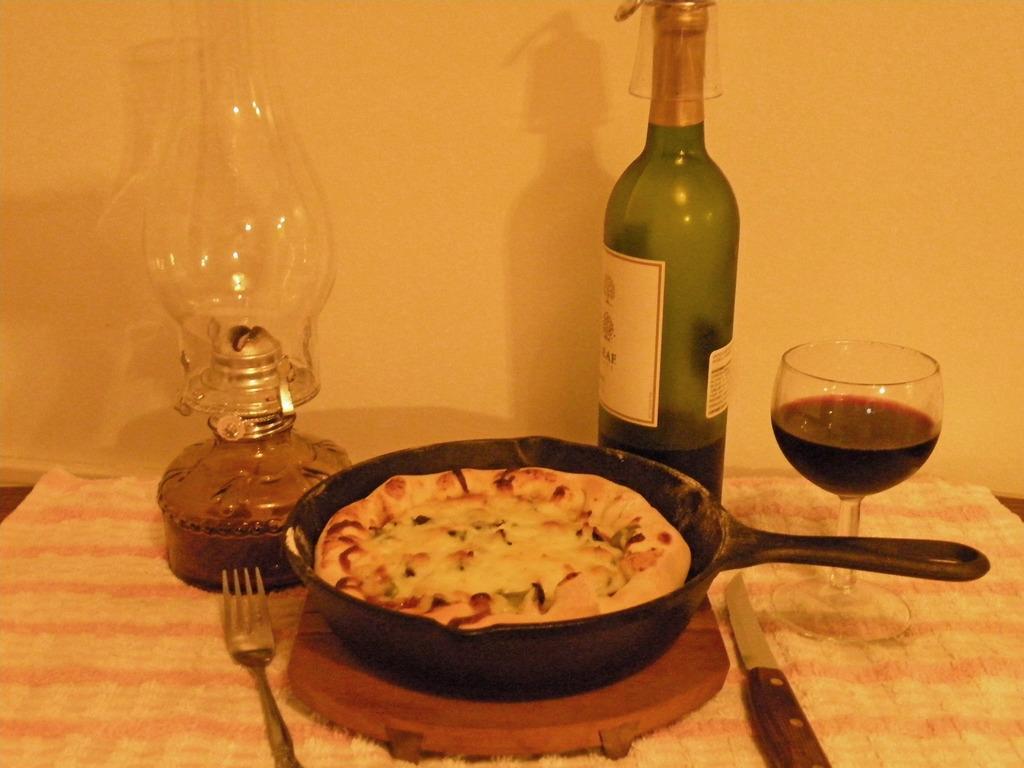Could you give a brief overview of what you see in this image? Picture consists of wall, table, tablecloth, pan, food, fork, knife, bottle and glass of wine. 